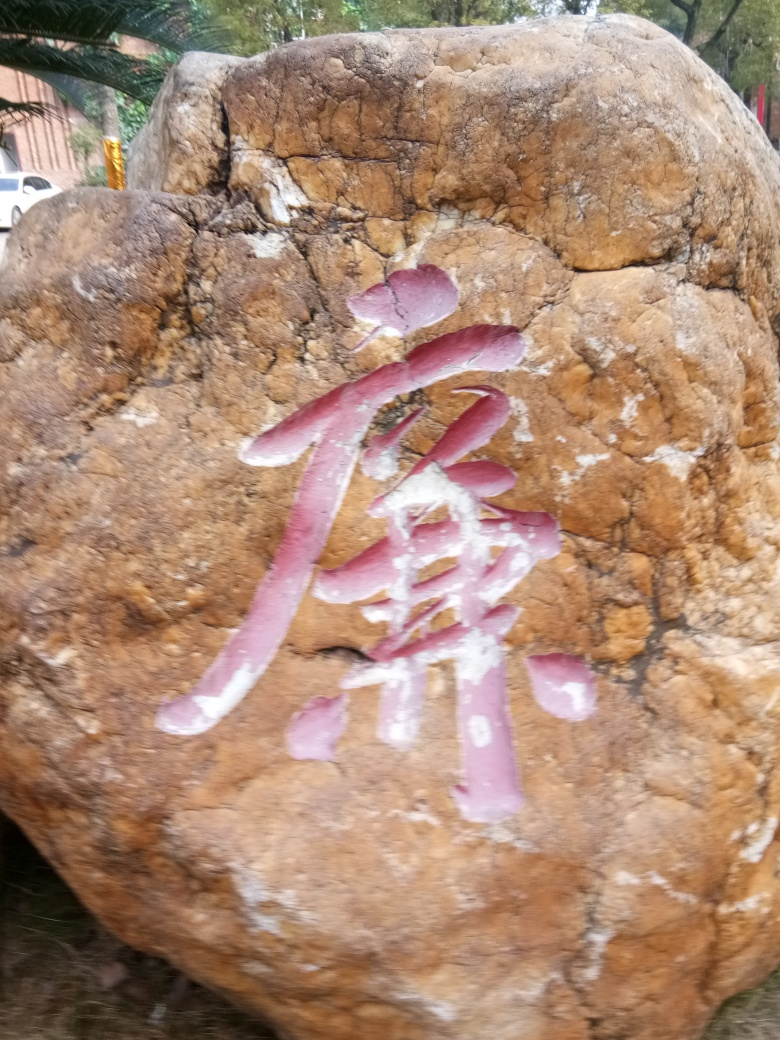Is there any cultural significance to these types of rock markings? Such markings on rocks can be related to various cultural practices, including commemorative inscriptions, religious expressions, or artistic endeavors. The specific cultural significance would depend on the origin and context of the markings, which, from this image alone, is not discernible. Could you infer anything else from this image? While inferences are limited given the image quality, the weathering on the rock suggests it has been exposed to the elements for a considerable time, possibly indicating that the marking is of some age or the location is prone to harsh weather. 